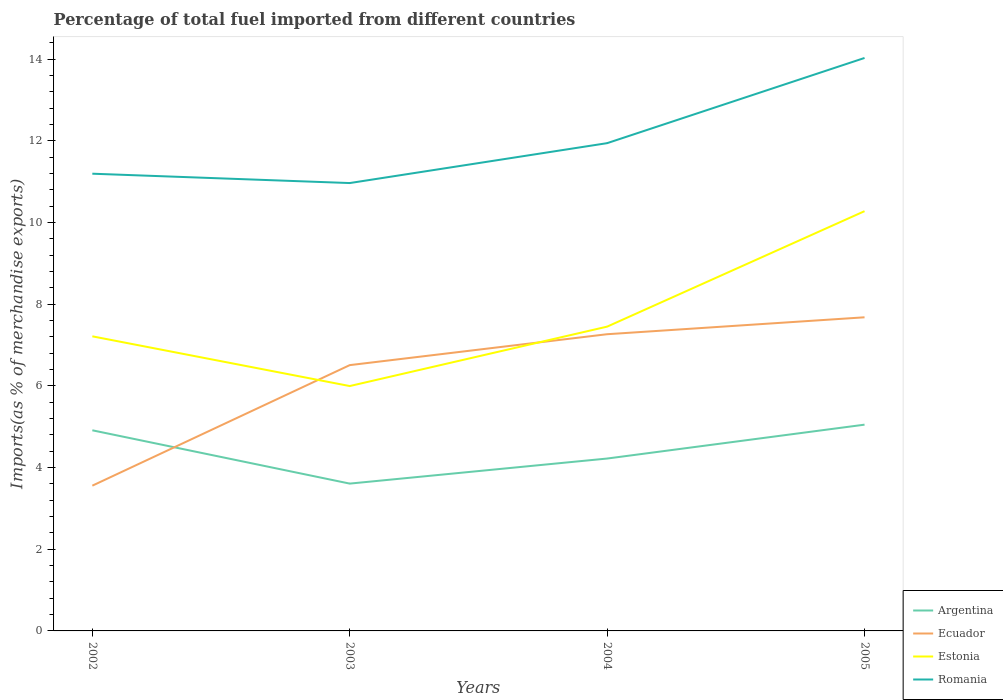How many different coloured lines are there?
Your answer should be very brief. 4. Does the line corresponding to Ecuador intersect with the line corresponding to Romania?
Your response must be concise. No. Is the number of lines equal to the number of legend labels?
Provide a short and direct response. Yes. Across all years, what is the maximum percentage of imports to different countries in Romania?
Your response must be concise. 10.97. In which year was the percentage of imports to different countries in Ecuador maximum?
Provide a succinct answer. 2002. What is the total percentage of imports to different countries in Argentina in the graph?
Keep it short and to the point. 0.69. What is the difference between the highest and the second highest percentage of imports to different countries in Argentina?
Make the answer very short. 1.44. What is the difference between the highest and the lowest percentage of imports to different countries in Romania?
Keep it short and to the point. 1. Is the percentage of imports to different countries in Estonia strictly greater than the percentage of imports to different countries in Argentina over the years?
Your answer should be very brief. No. How many lines are there?
Keep it short and to the point. 4. How many years are there in the graph?
Keep it short and to the point. 4. Does the graph contain any zero values?
Offer a very short reply. No. Where does the legend appear in the graph?
Ensure brevity in your answer.  Bottom right. How are the legend labels stacked?
Keep it short and to the point. Vertical. What is the title of the graph?
Provide a succinct answer. Percentage of total fuel imported from different countries. What is the label or title of the Y-axis?
Offer a very short reply. Imports(as % of merchandise exports). What is the Imports(as % of merchandise exports) of Argentina in 2002?
Your answer should be compact. 4.91. What is the Imports(as % of merchandise exports) of Ecuador in 2002?
Offer a terse response. 3.56. What is the Imports(as % of merchandise exports) in Estonia in 2002?
Provide a short and direct response. 7.22. What is the Imports(as % of merchandise exports) in Romania in 2002?
Your answer should be compact. 11.2. What is the Imports(as % of merchandise exports) in Argentina in 2003?
Your answer should be compact. 3.61. What is the Imports(as % of merchandise exports) of Ecuador in 2003?
Keep it short and to the point. 6.51. What is the Imports(as % of merchandise exports) of Estonia in 2003?
Make the answer very short. 6. What is the Imports(as % of merchandise exports) in Romania in 2003?
Your answer should be compact. 10.97. What is the Imports(as % of merchandise exports) of Argentina in 2004?
Offer a very short reply. 4.22. What is the Imports(as % of merchandise exports) of Ecuador in 2004?
Your answer should be very brief. 7.27. What is the Imports(as % of merchandise exports) of Estonia in 2004?
Your answer should be compact. 7.45. What is the Imports(as % of merchandise exports) in Romania in 2004?
Your answer should be very brief. 11.95. What is the Imports(as % of merchandise exports) of Argentina in 2005?
Your answer should be compact. 5.05. What is the Imports(as % of merchandise exports) in Ecuador in 2005?
Provide a succinct answer. 7.68. What is the Imports(as % of merchandise exports) in Estonia in 2005?
Ensure brevity in your answer.  10.28. What is the Imports(as % of merchandise exports) of Romania in 2005?
Your answer should be very brief. 14.03. Across all years, what is the maximum Imports(as % of merchandise exports) in Argentina?
Keep it short and to the point. 5.05. Across all years, what is the maximum Imports(as % of merchandise exports) in Ecuador?
Your answer should be very brief. 7.68. Across all years, what is the maximum Imports(as % of merchandise exports) of Estonia?
Offer a terse response. 10.28. Across all years, what is the maximum Imports(as % of merchandise exports) of Romania?
Make the answer very short. 14.03. Across all years, what is the minimum Imports(as % of merchandise exports) of Argentina?
Your answer should be very brief. 3.61. Across all years, what is the minimum Imports(as % of merchandise exports) in Ecuador?
Provide a short and direct response. 3.56. Across all years, what is the minimum Imports(as % of merchandise exports) of Estonia?
Provide a short and direct response. 6. Across all years, what is the minimum Imports(as % of merchandise exports) in Romania?
Give a very brief answer. 10.97. What is the total Imports(as % of merchandise exports) in Argentina in the graph?
Give a very brief answer. 17.8. What is the total Imports(as % of merchandise exports) in Ecuador in the graph?
Your answer should be very brief. 25.02. What is the total Imports(as % of merchandise exports) in Estonia in the graph?
Provide a short and direct response. 30.95. What is the total Imports(as % of merchandise exports) of Romania in the graph?
Keep it short and to the point. 48.15. What is the difference between the Imports(as % of merchandise exports) of Argentina in 2002 and that in 2003?
Give a very brief answer. 1.31. What is the difference between the Imports(as % of merchandise exports) of Ecuador in 2002 and that in 2003?
Your answer should be compact. -2.95. What is the difference between the Imports(as % of merchandise exports) in Estonia in 2002 and that in 2003?
Provide a succinct answer. 1.22. What is the difference between the Imports(as % of merchandise exports) in Romania in 2002 and that in 2003?
Your answer should be compact. 0.23. What is the difference between the Imports(as % of merchandise exports) in Argentina in 2002 and that in 2004?
Offer a very short reply. 0.69. What is the difference between the Imports(as % of merchandise exports) of Ecuador in 2002 and that in 2004?
Keep it short and to the point. -3.71. What is the difference between the Imports(as % of merchandise exports) of Estonia in 2002 and that in 2004?
Provide a succinct answer. -0.24. What is the difference between the Imports(as % of merchandise exports) of Romania in 2002 and that in 2004?
Your response must be concise. -0.75. What is the difference between the Imports(as % of merchandise exports) in Argentina in 2002 and that in 2005?
Your response must be concise. -0.14. What is the difference between the Imports(as % of merchandise exports) of Ecuador in 2002 and that in 2005?
Your answer should be very brief. -4.12. What is the difference between the Imports(as % of merchandise exports) in Estonia in 2002 and that in 2005?
Your answer should be very brief. -3.07. What is the difference between the Imports(as % of merchandise exports) of Romania in 2002 and that in 2005?
Keep it short and to the point. -2.83. What is the difference between the Imports(as % of merchandise exports) of Argentina in 2003 and that in 2004?
Your answer should be compact. -0.61. What is the difference between the Imports(as % of merchandise exports) in Ecuador in 2003 and that in 2004?
Offer a very short reply. -0.76. What is the difference between the Imports(as % of merchandise exports) in Estonia in 2003 and that in 2004?
Give a very brief answer. -1.46. What is the difference between the Imports(as % of merchandise exports) in Romania in 2003 and that in 2004?
Provide a succinct answer. -0.98. What is the difference between the Imports(as % of merchandise exports) in Argentina in 2003 and that in 2005?
Ensure brevity in your answer.  -1.44. What is the difference between the Imports(as % of merchandise exports) of Ecuador in 2003 and that in 2005?
Give a very brief answer. -1.17. What is the difference between the Imports(as % of merchandise exports) of Estonia in 2003 and that in 2005?
Make the answer very short. -4.28. What is the difference between the Imports(as % of merchandise exports) in Romania in 2003 and that in 2005?
Your answer should be very brief. -3.06. What is the difference between the Imports(as % of merchandise exports) in Argentina in 2004 and that in 2005?
Provide a short and direct response. -0.83. What is the difference between the Imports(as % of merchandise exports) of Ecuador in 2004 and that in 2005?
Give a very brief answer. -0.41. What is the difference between the Imports(as % of merchandise exports) in Estonia in 2004 and that in 2005?
Give a very brief answer. -2.83. What is the difference between the Imports(as % of merchandise exports) in Romania in 2004 and that in 2005?
Ensure brevity in your answer.  -2.09. What is the difference between the Imports(as % of merchandise exports) in Argentina in 2002 and the Imports(as % of merchandise exports) in Ecuador in 2003?
Offer a terse response. -1.6. What is the difference between the Imports(as % of merchandise exports) of Argentina in 2002 and the Imports(as % of merchandise exports) of Estonia in 2003?
Provide a short and direct response. -1.08. What is the difference between the Imports(as % of merchandise exports) in Argentina in 2002 and the Imports(as % of merchandise exports) in Romania in 2003?
Give a very brief answer. -6.06. What is the difference between the Imports(as % of merchandise exports) of Ecuador in 2002 and the Imports(as % of merchandise exports) of Estonia in 2003?
Keep it short and to the point. -2.44. What is the difference between the Imports(as % of merchandise exports) in Ecuador in 2002 and the Imports(as % of merchandise exports) in Romania in 2003?
Your answer should be compact. -7.41. What is the difference between the Imports(as % of merchandise exports) in Estonia in 2002 and the Imports(as % of merchandise exports) in Romania in 2003?
Offer a very short reply. -3.75. What is the difference between the Imports(as % of merchandise exports) in Argentina in 2002 and the Imports(as % of merchandise exports) in Ecuador in 2004?
Ensure brevity in your answer.  -2.35. What is the difference between the Imports(as % of merchandise exports) of Argentina in 2002 and the Imports(as % of merchandise exports) of Estonia in 2004?
Your answer should be compact. -2.54. What is the difference between the Imports(as % of merchandise exports) in Argentina in 2002 and the Imports(as % of merchandise exports) in Romania in 2004?
Offer a very short reply. -7.03. What is the difference between the Imports(as % of merchandise exports) of Ecuador in 2002 and the Imports(as % of merchandise exports) of Estonia in 2004?
Ensure brevity in your answer.  -3.9. What is the difference between the Imports(as % of merchandise exports) in Ecuador in 2002 and the Imports(as % of merchandise exports) in Romania in 2004?
Make the answer very short. -8.39. What is the difference between the Imports(as % of merchandise exports) in Estonia in 2002 and the Imports(as % of merchandise exports) in Romania in 2004?
Provide a short and direct response. -4.73. What is the difference between the Imports(as % of merchandise exports) of Argentina in 2002 and the Imports(as % of merchandise exports) of Ecuador in 2005?
Give a very brief answer. -2.77. What is the difference between the Imports(as % of merchandise exports) of Argentina in 2002 and the Imports(as % of merchandise exports) of Estonia in 2005?
Provide a succinct answer. -5.37. What is the difference between the Imports(as % of merchandise exports) of Argentina in 2002 and the Imports(as % of merchandise exports) of Romania in 2005?
Your answer should be compact. -9.12. What is the difference between the Imports(as % of merchandise exports) in Ecuador in 2002 and the Imports(as % of merchandise exports) in Estonia in 2005?
Provide a short and direct response. -6.72. What is the difference between the Imports(as % of merchandise exports) of Ecuador in 2002 and the Imports(as % of merchandise exports) of Romania in 2005?
Your answer should be compact. -10.48. What is the difference between the Imports(as % of merchandise exports) in Estonia in 2002 and the Imports(as % of merchandise exports) in Romania in 2005?
Make the answer very short. -6.82. What is the difference between the Imports(as % of merchandise exports) of Argentina in 2003 and the Imports(as % of merchandise exports) of Ecuador in 2004?
Provide a short and direct response. -3.66. What is the difference between the Imports(as % of merchandise exports) in Argentina in 2003 and the Imports(as % of merchandise exports) in Estonia in 2004?
Offer a terse response. -3.84. What is the difference between the Imports(as % of merchandise exports) of Argentina in 2003 and the Imports(as % of merchandise exports) of Romania in 2004?
Offer a very short reply. -8.34. What is the difference between the Imports(as % of merchandise exports) in Ecuador in 2003 and the Imports(as % of merchandise exports) in Estonia in 2004?
Keep it short and to the point. -0.94. What is the difference between the Imports(as % of merchandise exports) of Ecuador in 2003 and the Imports(as % of merchandise exports) of Romania in 2004?
Your response must be concise. -5.44. What is the difference between the Imports(as % of merchandise exports) of Estonia in 2003 and the Imports(as % of merchandise exports) of Romania in 2004?
Make the answer very short. -5.95. What is the difference between the Imports(as % of merchandise exports) of Argentina in 2003 and the Imports(as % of merchandise exports) of Ecuador in 2005?
Your answer should be very brief. -4.07. What is the difference between the Imports(as % of merchandise exports) in Argentina in 2003 and the Imports(as % of merchandise exports) in Estonia in 2005?
Your answer should be compact. -6.67. What is the difference between the Imports(as % of merchandise exports) of Argentina in 2003 and the Imports(as % of merchandise exports) of Romania in 2005?
Provide a short and direct response. -10.43. What is the difference between the Imports(as % of merchandise exports) of Ecuador in 2003 and the Imports(as % of merchandise exports) of Estonia in 2005?
Offer a terse response. -3.77. What is the difference between the Imports(as % of merchandise exports) in Ecuador in 2003 and the Imports(as % of merchandise exports) in Romania in 2005?
Your response must be concise. -7.52. What is the difference between the Imports(as % of merchandise exports) in Estonia in 2003 and the Imports(as % of merchandise exports) in Romania in 2005?
Provide a short and direct response. -8.04. What is the difference between the Imports(as % of merchandise exports) in Argentina in 2004 and the Imports(as % of merchandise exports) in Ecuador in 2005?
Ensure brevity in your answer.  -3.46. What is the difference between the Imports(as % of merchandise exports) in Argentina in 2004 and the Imports(as % of merchandise exports) in Estonia in 2005?
Keep it short and to the point. -6.06. What is the difference between the Imports(as % of merchandise exports) in Argentina in 2004 and the Imports(as % of merchandise exports) in Romania in 2005?
Offer a terse response. -9.81. What is the difference between the Imports(as % of merchandise exports) in Ecuador in 2004 and the Imports(as % of merchandise exports) in Estonia in 2005?
Offer a very short reply. -3.01. What is the difference between the Imports(as % of merchandise exports) of Ecuador in 2004 and the Imports(as % of merchandise exports) of Romania in 2005?
Your answer should be compact. -6.77. What is the difference between the Imports(as % of merchandise exports) of Estonia in 2004 and the Imports(as % of merchandise exports) of Romania in 2005?
Offer a terse response. -6.58. What is the average Imports(as % of merchandise exports) of Argentina per year?
Keep it short and to the point. 4.45. What is the average Imports(as % of merchandise exports) in Ecuador per year?
Your answer should be compact. 6.25. What is the average Imports(as % of merchandise exports) of Estonia per year?
Your answer should be compact. 7.74. What is the average Imports(as % of merchandise exports) in Romania per year?
Give a very brief answer. 12.04. In the year 2002, what is the difference between the Imports(as % of merchandise exports) in Argentina and Imports(as % of merchandise exports) in Ecuador?
Give a very brief answer. 1.36. In the year 2002, what is the difference between the Imports(as % of merchandise exports) of Argentina and Imports(as % of merchandise exports) of Estonia?
Provide a succinct answer. -2.3. In the year 2002, what is the difference between the Imports(as % of merchandise exports) of Argentina and Imports(as % of merchandise exports) of Romania?
Keep it short and to the point. -6.28. In the year 2002, what is the difference between the Imports(as % of merchandise exports) of Ecuador and Imports(as % of merchandise exports) of Estonia?
Provide a succinct answer. -3.66. In the year 2002, what is the difference between the Imports(as % of merchandise exports) in Ecuador and Imports(as % of merchandise exports) in Romania?
Your answer should be compact. -7.64. In the year 2002, what is the difference between the Imports(as % of merchandise exports) in Estonia and Imports(as % of merchandise exports) in Romania?
Make the answer very short. -3.98. In the year 2003, what is the difference between the Imports(as % of merchandise exports) of Argentina and Imports(as % of merchandise exports) of Ecuador?
Offer a terse response. -2.9. In the year 2003, what is the difference between the Imports(as % of merchandise exports) in Argentina and Imports(as % of merchandise exports) in Estonia?
Offer a very short reply. -2.39. In the year 2003, what is the difference between the Imports(as % of merchandise exports) of Argentina and Imports(as % of merchandise exports) of Romania?
Offer a terse response. -7.36. In the year 2003, what is the difference between the Imports(as % of merchandise exports) in Ecuador and Imports(as % of merchandise exports) in Estonia?
Offer a very short reply. 0.51. In the year 2003, what is the difference between the Imports(as % of merchandise exports) of Ecuador and Imports(as % of merchandise exports) of Romania?
Your response must be concise. -4.46. In the year 2003, what is the difference between the Imports(as % of merchandise exports) of Estonia and Imports(as % of merchandise exports) of Romania?
Keep it short and to the point. -4.97. In the year 2004, what is the difference between the Imports(as % of merchandise exports) of Argentina and Imports(as % of merchandise exports) of Ecuador?
Your response must be concise. -3.05. In the year 2004, what is the difference between the Imports(as % of merchandise exports) of Argentina and Imports(as % of merchandise exports) of Estonia?
Your response must be concise. -3.23. In the year 2004, what is the difference between the Imports(as % of merchandise exports) of Argentina and Imports(as % of merchandise exports) of Romania?
Ensure brevity in your answer.  -7.72. In the year 2004, what is the difference between the Imports(as % of merchandise exports) in Ecuador and Imports(as % of merchandise exports) in Estonia?
Your response must be concise. -0.19. In the year 2004, what is the difference between the Imports(as % of merchandise exports) of Ecuador and Imports(as % of merchandise exports) of Romania?
Offer a very short reply. -4.68. In the year 2004, what is the difference between the Imports(as % of merchandise exports) of Estonia and Imports(as % of merchandise exports) of Romania?
Give a very brief answer. -4.49. In the year 2005, what is the difference between the Imports(as % of merchandise exports) of Argentina and Imports(as % of merchandise exports) of Ecuador?
Give a very brief answer. -2.63. In the year 2005, what is the difference between the Imports(as % of merchandise exports) in Argentina and Imports(as % of merchandise exports) in Estonia?
Ensure brevity in your answer.  -5.23. In the year 2005, what is the difference between the Imports(as % of merchandise exports) in Argentina and Imports(as % of merchandise exports) in Romania?
Your response must be concise. -8.98. In the year 2005, what is the difference between the Imports(as % of merchandise exports) in Ecuador and Imports(as % of merchandise exports) in Estonia?
Provide a succinct answer. -2.6. In the year 2005, what is the difference between the Imports(as % of merchandise exports) of Ecuador and Imports(as % of merchandise exports) of Romania?
Make the answer very short. -6.35. In the year 2005, what is the difference between the Imports(as % of merchandise exports) of Estonia and Imports(as % of merchandise exports) of Romania?
Offer a terse response. -3.75. What is the ratio of the Imports(as % of merchandise exports) of Argentina in 2002 to that in 2003?
Offer a very short reply. 1.36. What is the ratio of the Imports(as % of merchandise exports) in Ecuador in 2002 to that in 2003?
Keep it short and to the point. 0.55. What is the ratio of the Imports(as % of merchandise exports) in Estonia in 2002 to that in 2003?
Provide a succinct answer. 1.2. What is the ratio of the Imports(as % of merchandise exports) of Romania in 2002 to that in 2003?
Ensure brevity in your answer.  1.02. What is the ratio of the Imports(as % of merchandise exports) in Argentina in 2002 to that in 2004?
Your response must be concise. 1.16. What is the ratio of the Imports(as % of merchandise exports) of Ecuador in 2002 to that in 2004?
Give a very brief answer. 0.49. What is the ratio of the Imports(as % of merchandise exports) of Estonia in 2002 to that in 2004?
Your answer should be very brief. 0.97. What is the ratio of the Imports(as % of merchandise exports) in Romania in 2002 to that in 2004?
Ensure brevity in your answer.  0.94. What is the ratio of the Imports(as % of merchandise exports) in Argentina in 2002 to that in 2005?
Your response must be concise. 0.97. What is the ratio of the Imports(as % of merchandise exports) of Ecuador in 2002 to that in 2005?
Offer a very short reply. 0.46. What is the ratio of the Imports(as % of merchandise exports) in Estonia in 2002 to that in 2005?
Your answer should be compact. 0.7. What is the ratio of the Imports(as % of merchandise exports) of Romania in 2002 to that in 2005?
Make the answer very short. 0.8. What is the ratio of the Imports(as % of merchandise exports) in Argentina in 2003 to that in 2004?
Keep it short and to the point. 0.85. What is the ratio of the Imports(as % of merchandise exports) in Ecuador in 2003 to that in 2004?
Provide a short and direct response. 0.9. What is the ratio of the Imports(as % of merchandise exports) in Estonia in 2003 to that in 2004?
Ensure brevity in your answer.  0.8. What is the ratio of the Imports(as % of merchandise exports) of Romania in 2003 to that in 2004?
Your answer should be compact. 0.92. What is the ratio of the Imports(as % of merchandise exports) in Argentina in 2003 to that in 2005?
Your response must be concise. 0.71. What is the ratio of the Imports(as % of merchandise exports) of Ecuador in 2003 to that in 2005?
Your answer should be compact. 0.85. What is the ratio of the Imports(as % of merchandise exports) of Estonia in 2003 to that in 2005?
Give a very brief answer. 0.58. What is the ratio of the Imports(as % of merchandise exports) of Romania in 2003 to that in 2005?
Offer a terse response. 0.78. What is the ratio of the Imports(as % of merchandise exports) of Argentina in 2004 to that in 2005?
Your answer should be very brief. 0.84. What is the ratio of the Imports(as % of merchandise exports) of Ecuador in 2004 to that in 2005?
Keep it short and to the point. 0.95. What is the ratio of the Imports(as % of merchandise exports) in Estonia in 2004 to that in 2005?
Provide a succinct answer. 0.72. What is the ratio of the Imports(as % of merchandise exports) of Romania in 2004 to that in 2005?
Offer a terse response. 0.85. What is the difference between the highest and the second highest Imports(as % of merchandise exports) of Argentina?
Your answer should be very brief. 0.14. What is the difference between the highest and the second highest Imports(as % of merchandise exports) in Ecuador?
Give a very brief answer. 0.41. What is the difference between the highest and the second highest Imports(as % of merchandise exports) in Estonia?
Make the answer very short. 2.83. What is the difference between the highest and the second highest Imports(as % of merchandise exports) of Romania?
Your answer should be compact. 2.09. What is the difference between the highest and the lowest Imports(as % of merchandise exports) in Argentina?
Provide a short and direct response. 1.44. What is the difference between the highest and the lowest Imports(as % of merchandise exports) in Ecuador?
Ensure brevity in your answer.  4.12. What is the difference between the highest and the lowest Imports(as % of merchandise exports) in Estonia?
Give a very brief answer. 4.28. What is the difference between the highest and the lowest Imports(as % of merchandise exports) in Romania?
Offer a terse response. 3.06. 